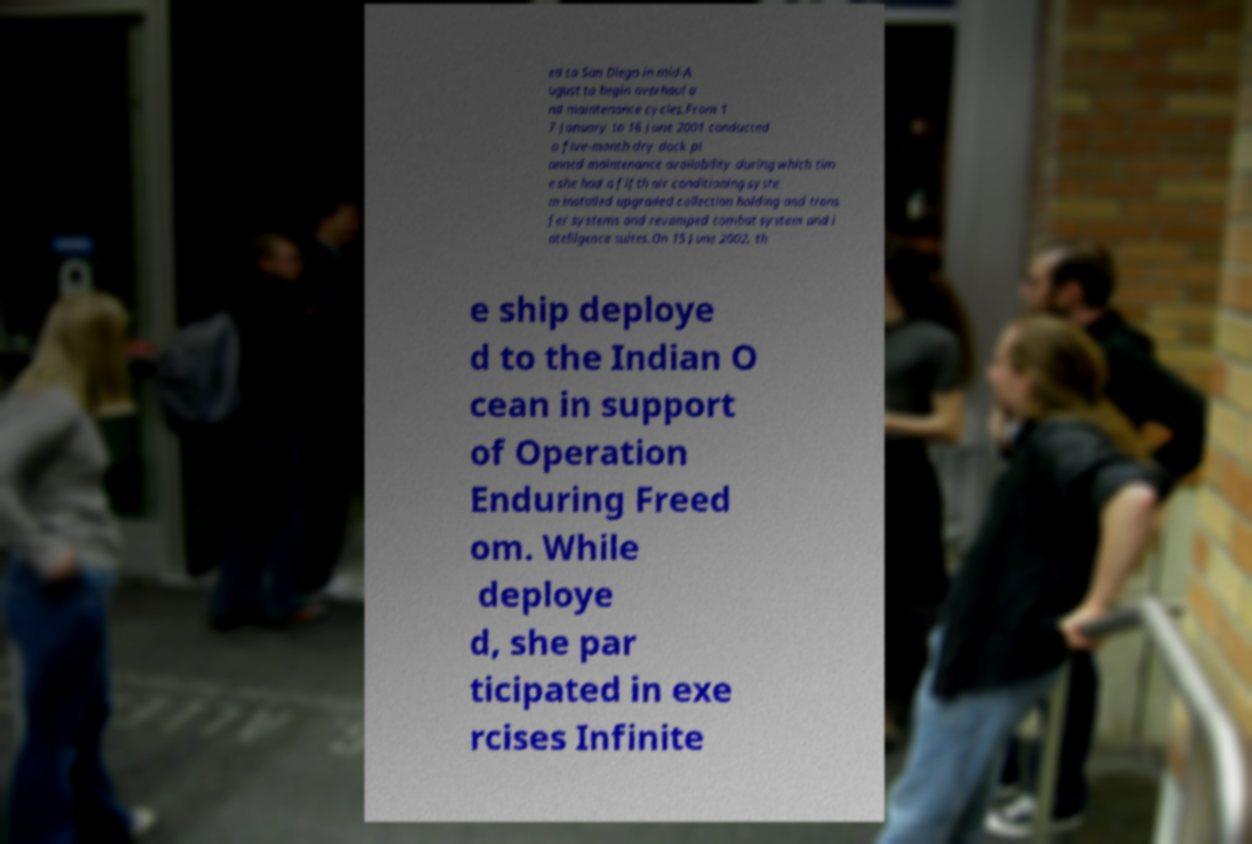Can you read and provide the text displayed in the image?This photo seems to have some interesting text. Can you extract and type it out for me? ed to San Diego in mid-A ugust to begin overhaul a nd maintenance cycles.From 1 7 January to 16 June 2001 conducted a five-month dry dock pl anned maintenance availability during which tim e she had a fifth air conditioning syste m installed upgraded collection holding and trans fer systems and revamped combat system and i ntelligence suites.On 15 June 2002, th e ship deploye d to the Indian O cean in support of Operation Enduring Freed om. While deploye d, she par ticipated in exe rcises Infinite 